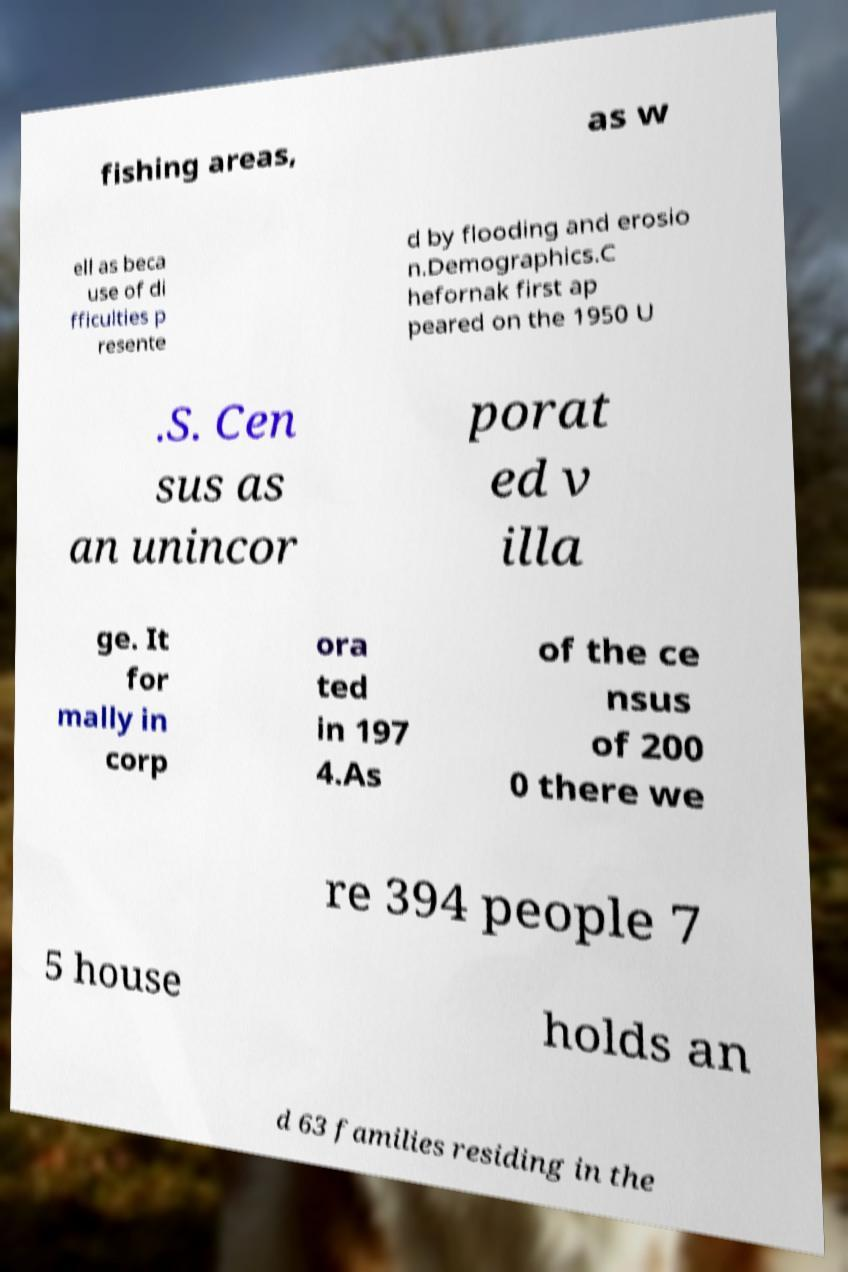Could you extract and type out the text from this image? fishing areas, as w ell as beca use of di fficulties p resente d by flooding and erosio n.Demographics.C hefornak first ap peared on the 1950 U .S. Cen sus as an unincor porat ed v illa ge. It for mally in corp ora ted in 197 4.As of the ce nsus of 200 0 there we re 394 people 7 5 house holds an d 63 families residing in the 